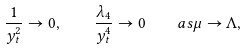<formula> <loc_0><loc_0><loc_500><loc_500>\frac { 1 } { y _ { t } ^ { 2 } } \rightarrow 0 , \quad \frac { \lambda _ { 4 } } { y _ { t } ^ { 4 } } \rightarrow 0 \quad a s \mu \rightarrow \Lambda ,</formula> 